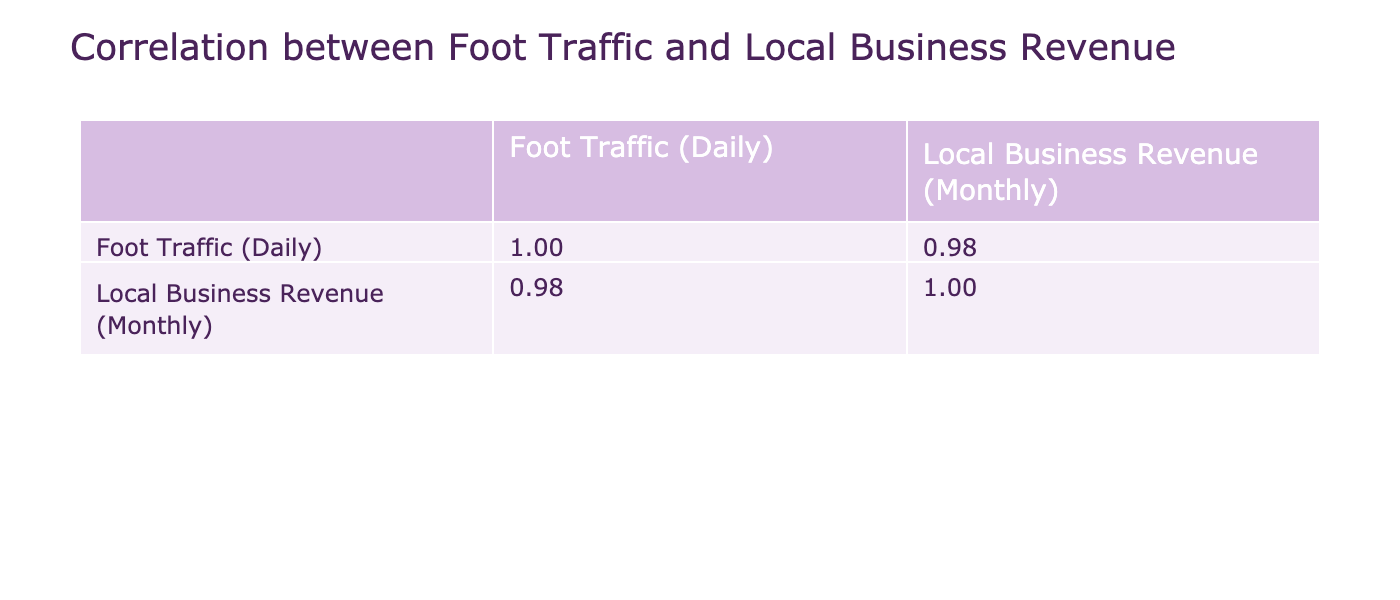What is the foot traffic at Gateway Arch? The table shows the specific value of foot traffic for each landmark. For Gateway Arch, the row indicates a foot traffic value of 1500 daily.
Answer: 1500 What is the local business revenue for the St. Louis Art Museum? By looking at the row for St. Louis Art Museum, we can see that the local business revenue is stated as 20000 monthly.
Answer: 20000 Is there a correlation value between foot traffic and local business revenue? The correlation matrix indicates the relationship between foot traffic and local business revenue. It shows that the correlation is positive, meaning foot traffic likely influences business revenue.
Answer: Yes Does the foot traffic at Busch Stadium exceed 2500? The table indicates that Busch Stadium has a foot traffic value of 3000 daily, which is greater than 2500.
Answer: Yes What is the difference in monthly revenue between the highest and lowest foot traffic landmarks? To find this, look for the highest foot traffic, which is 3000 at Busch Stadium (70000 monthly revenue), and the lowest, which is 300 at Saint Louis Cathedral (10000 monthly revenue). The difference in revenue is calculated as 70000 - 10000 = 60000.
Answer: 60000 Are there any local businesses near the Forest Park that match with a foot traffic of 1200? The table specifies that the nearby business type for Forest Park (with 1200 foot traffic) is Café, confirming it matches the foot traffic value mentioned.
Answer: Yes What is the average local business revenue for the top three landmarks by foot traffic? The top three landmarks by foot traffic are Busch Stadium (70000), Lumiere Place Casino (60000), and Anheuser-Busch Brewery (50000). Adding these gives 70000 + 60000 + 50000 = 180000. Dividing by 3 gives an average of 180000 / 3 = 60000.
Answer: 60000 Is there a landmark with a local business revenue above 40000 that has foot traffic less than 1000? By inspecting the table, we note that there are no landmarks with a revenue above 40000 and foot traffic below 1000, as lower revenue values align with lower foot traffic in this dataset.
Answer: No 